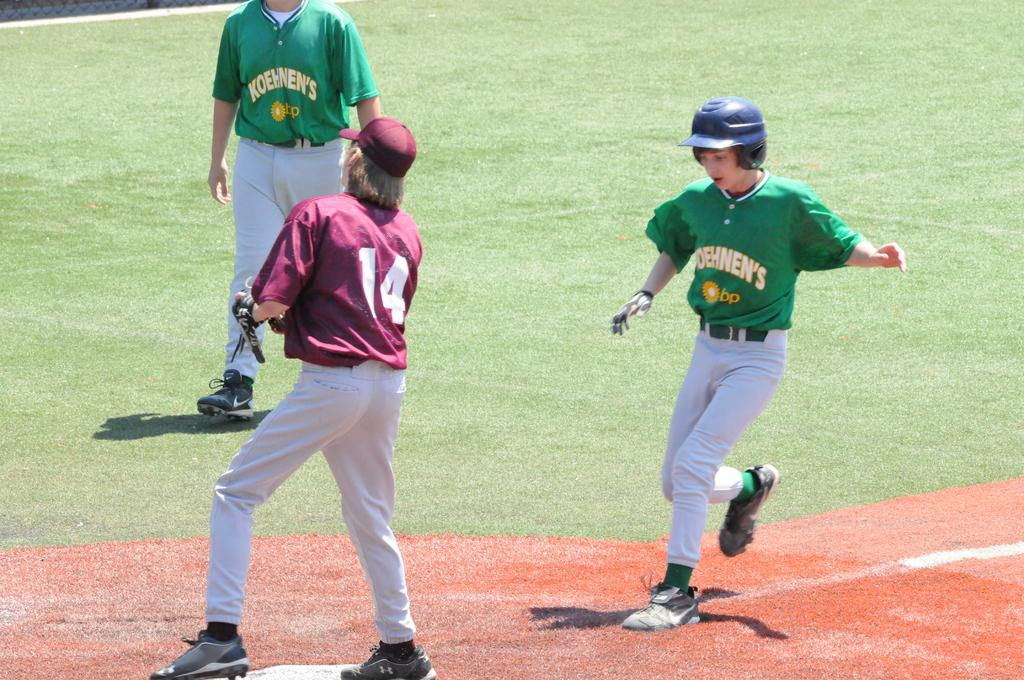<image>
Create a compact narrative representing the image presented. A baseball player in green approaches the base where 14 is standing. 